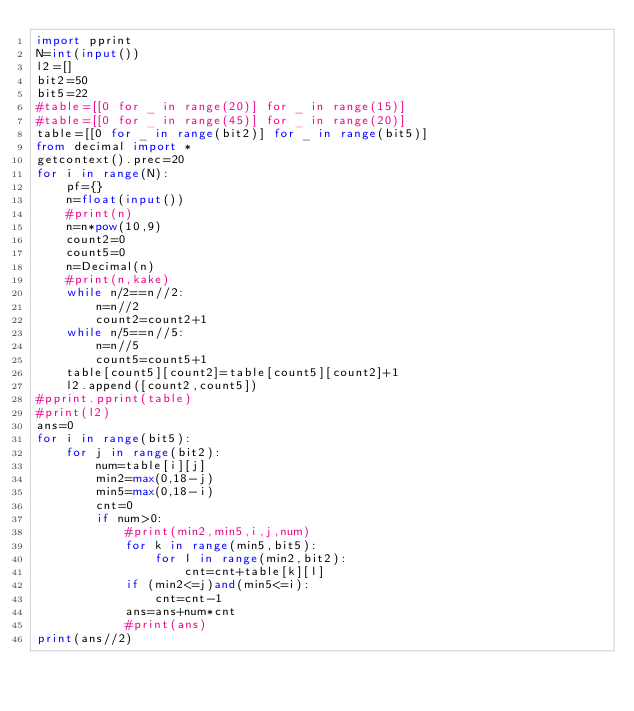Convert code to text. <code><loc_0><loc_0><loc_500><loc_500><_Python_>import pprint
N=int(input())
l2=[]
bit2=50
bit5=22
#table=[[0 for _ in range(20)] for _ in range(15)]
#table=[[0 for _ in range(45)] for _ in range(20)]
table=[[0 for _ in range(bit2)] for _ in range(bit5)]
from decimal import *
getcontext().prec=20
for i in range(N):
    pf={}
    n=float(input())
    #print(n)
    n=n*pow(10,9)
    count2=0
    count5=0
    n=Decimal(n)
    #print(n,kake)
    while n/2==n//2:
        n=n//2
        count2=count2+1
    while n/5==n//5:
        n=n//5
        count5=count5+1
    table[count5][count2]=table[count5][count2]+1
    l2.append([count2,count5])
#pprint.pprint(table)
#print(l2)
ans=0
for i in range(bit5):
    for j in range(bit2):
        num=table[i][j]
        min2=max(0,18-j)
        min5=max(0,18-i)
        cnt=0
        if num>0:
            #print(min2,min5,i,j,num)
            for k in range(min5,bit5):
                for l in range(min2,bit2):
                    cnt=cnt+table[k][l]
            if (min2<=j)and(min5<=i):
                cnt=cnt-1
            ans=ans+num*cnt
            #print(ans)
print(ans//2)

</code> 